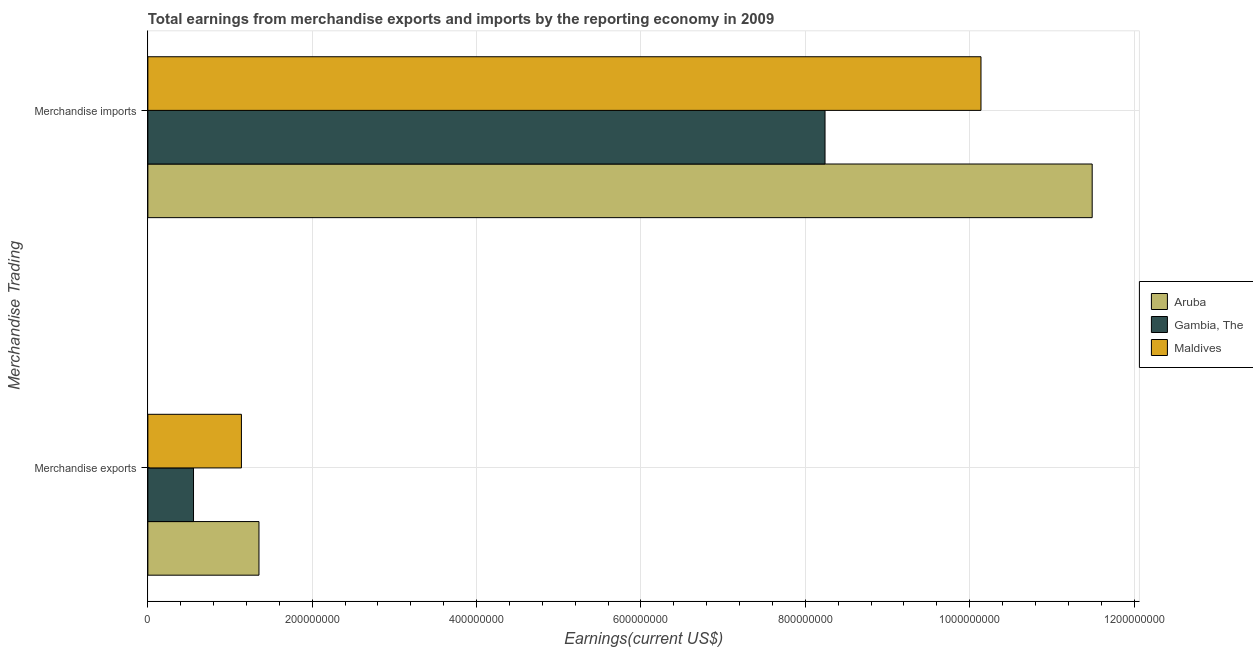How many different coloured bars are there?
Provide a short and direct response. 3. Are the number of bars per tick equal to the number of legend labels?
Offer a very short reply. Yes. How many bars are there on the 2nd tick from the top?
Provide a short and direct response. 3. What is the earnings from merchandise exports in Gambia, The?
Keep it short and to the point. 5.56e+07. Across all countries, what is the maximum earnings from merchandise exports?
Make the answer very short. 1.35e+08. Across all countries, what is the minimum earnings from merchandise exports?
Your answer should be very brief. 5.56e+07. In which country was the earnings from merchandise imports maximum?
Provide a succinct answer. Aruba. In which country was the earnings from merchandise imports minimum?
Your response must be concise. Gambia, The. What is the total earnings from merchandise imports in the graph?
Keep it short and to the point. 2.99e+09. What is the difference between the earnings from merchandise exports in Aruba and that in Maldives?
Offer a terse response. 2.13e+07. What is the difference between the earnings from merchandise exports in Gambia, The and the earnings from merchandise imports in Aruba?
Offer a terse response. -1.09e+09. What is the average earnings from merchandise imports per country?
Give a very brief answer. 9.96e+08. What is the difference between the earnings from merchandise exports and earnings from merchandise imports in Gambia, The?
Offer a terse response. -7.68e+08. What is the ratio of the earnings from merchandise exports in Aruba to that in Maldives?
Provide a short and direct response. 1.19. Is the earnings from merchandise imports in Maldives less than that in Gambia, The?
Provide a succinct answer. No. What does the 1st bar from the top in Merchandise exports represents?
Offer a very short reply. Maldives. What does the 1st bar from the bottom in Merchandise imports represents?
Provide a short and direct response. Aruba. How many countries are there in the graph?
Give a very brief answer. 3. Does the graph contain any zero values?
Ensure brevity in your answer.  No. Does the graph contain grids?
Your response must be concise. Yes. Where does the legend appear in the graph?
Give a very brief answer. Center right. How are the legend labels stacked?
Your answer should be very brief. Vertical. What is the title of the graph?
Ensure brevity in your answer.  Total earnings from merchandise exports and imports by the reporting economy in 2009. What is the label or title of the X-axis?
Ensure brevity in your answer.  Earnings(current US$). What is the label or title of the Y-axis?
Keep it short and to the point. Merchandise Trading. What is the Earnings(current US$) of Aruba in Merchandise exports?
Your answer should be very brief. 1.35e+08. What is the Earnings(current US$) in Gambia, The in Merchandise exports?
Provide a succinct answer. 5.56e+07. What is the Earnings(current US$) of Maldives in Merchandise exports?
Ensure brevity in your answer.  1.14e+08. What is the Earnings(current US$) of Aruba in Merchandise imports?
Your answer should be very brief. 1.15e+09. What is the Earnings(current US$) of Gambia, The in Merchandise imports?
Your response must be concise. 8.24e+08. What is the Earnings(current US$) in Maldives in Merchandise imports?
Your response must be concise. 1.01e+09. Across all Merchandise Trading, what is the maximum Earnings(current US$) of Aruba?
Keep it short and to the point. 1.15e+09. Across all Merchandise Trading, what is the maximum Earnings(current US$) in Gambia, The?
Provide a succinct answer. 8.24e+08. Across all Merchandise Trading, what is the maximum Earnings(current US$) of Maldives?
Offer a very short reply. 1.01e+09. Across all Merchandise Trading, what is the minimum Earnings(current US$) in Aruba?
Make the answer very short. 1.35e+08. Across all Merchandise Trading, what is the minimum Earnings(current US$) of Gambia, The?
Offer a terse response. 5.56e+07. Across all Merchandise Trading, what is the minimum Earnings(current US$) of Maldives?
Provide a succinct answer. 1.14e+08. What is the total Earnings(current US$) of Aruba in the graph?
Provide a short and direct response. 1.28e+09. What is the total Earnings(current US$) in Gambia, The in the graph?
Your answer should be very brief. 8.80e+08. What is the total Earnings(current US$) of Maldives in the graph?
Provide a short and direct response. 1.13e+09. What is the difference between the Earnings(current US$) of Aruba in Merchandise exports and that in Merchandise imports?
Make the answer very short. -1.01e+09. What is the difference between the Earnings(current US$) of Gambia, The in Merchandise exports and that in Merchandise imports?
Your answer should be compact. -7.68e+08. What is the difference between the Earnings(current US$) of Maldives in Merchandise exports and that in Merchandise imports?
Give a very brief answer. -9.00e+08. What is the difference between the Earnings(current US$) in Aruba in Merchandise exports and the Earnings(current US$) in Gambia, The in Merchandise imports?
Keep it short and to the point. -6.89e+08. What is the difference between the Earnings(current US$) of Aruba in Merchandise exports and the Earnings(current US$) of Maldives in Merchandise imports?
Offer a terse response. -8.79e+08. What is the difference between the Earnings(current US$) of Gambia, The in Merchandise exports and the Earnings(current US$) of Maldives in Merchandise imports?
Ensure brevity in your answer.  -9.58e+08. What is the average Earnings(current US$) of Aruba per Merchandise Trading?
Offer a very short reply. 6.42e+08. What is the average Earnings(current US$) in Gambia, The per Merchandise Trading?
Your answer should be compact. 4.40e+08. What is the average Earnings(current US$) in Maldives per Merchandise Trading?
Your answer should be very brief. 5.64e+08. What is the difference between the Earnings(current US$) of Aruba and Earnings(current US$) of Gambia, The in Merchandise exports?
Make the answer very short. 7.96e+07. What is the difference between the Earnings(current US$) of Aruba and Earnings(current US$) of Maldives in Merchandise exports?
Give a very brief answer. 2.13e+07. What is the difference between the Earnings(current US$) of Gambia, The and Earnings(current US$) of Maldives in Merchandise exports?
Your answer should be compact. -5.83e+07. What is the difference between the Earnings(current US$) of Aruba and Earnings(current US$) of Gambia, The in Merchandise imports?
Ensure brevity in your answer.  3.25e+08. What is the difference between the Earnings(current US$) in Aruba and Earnings(current US$) in Maldives in Merchandise imports?
Provide a succinct answer. 1.35e+08. What is the difference between the Earnings(current US$) of Gambia, The and Earnings(current US$) of Maldives in Merchandise imports?
Your answer should be very brief. -1.90e+08. What is the ratio of the Earnings(current US$) of Aruba in Merchandise exports to that in Merchandise imports?
Provide a short and direct response. 0.12. What is the ratio of the Earnings(current US$) of Gambia, The in Merchandise exports to that in Merchandise imports?
Your answer should be very brief. 0.07. What is the ratio of the Earnings(current US$) in Maldives in Merchandise exports to that in Merchandise imports?
Keep it short and to the point. 0.11. What is the difference between the highest and the second highest Earnings(current US$) in Aruba?
Your response must be concise. 1.01e+09. What is the difference between the highest and the second highest Earnings(current US$) in Gambia, The?
Offer a terse response. 7.68e+08. What is the difference between the highest and the second highest Earnings(current US$) in Maldives?
Ensure brevity in your answer.  9.00e+08. What is the difference between the highest and the lowest Earnings(current US$) in Aruba?
Ensure brevity in your answer.  1.01e+09. What is the difference between the highest and the lowest Earnings(current US$) of Gambia, The?
Give a very brief answer. 7.68e+08. What is the difference between the highest and the lowest Earnings(current US$) in Maldives?
Your answer should be compact. 9.00e+08. 